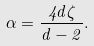Convert formula to latex. <formula><loc_0><loc_0><loc_500><loc_500>\alpha = \frac { 4 d \zeta } { d - 2 } .</formula> 